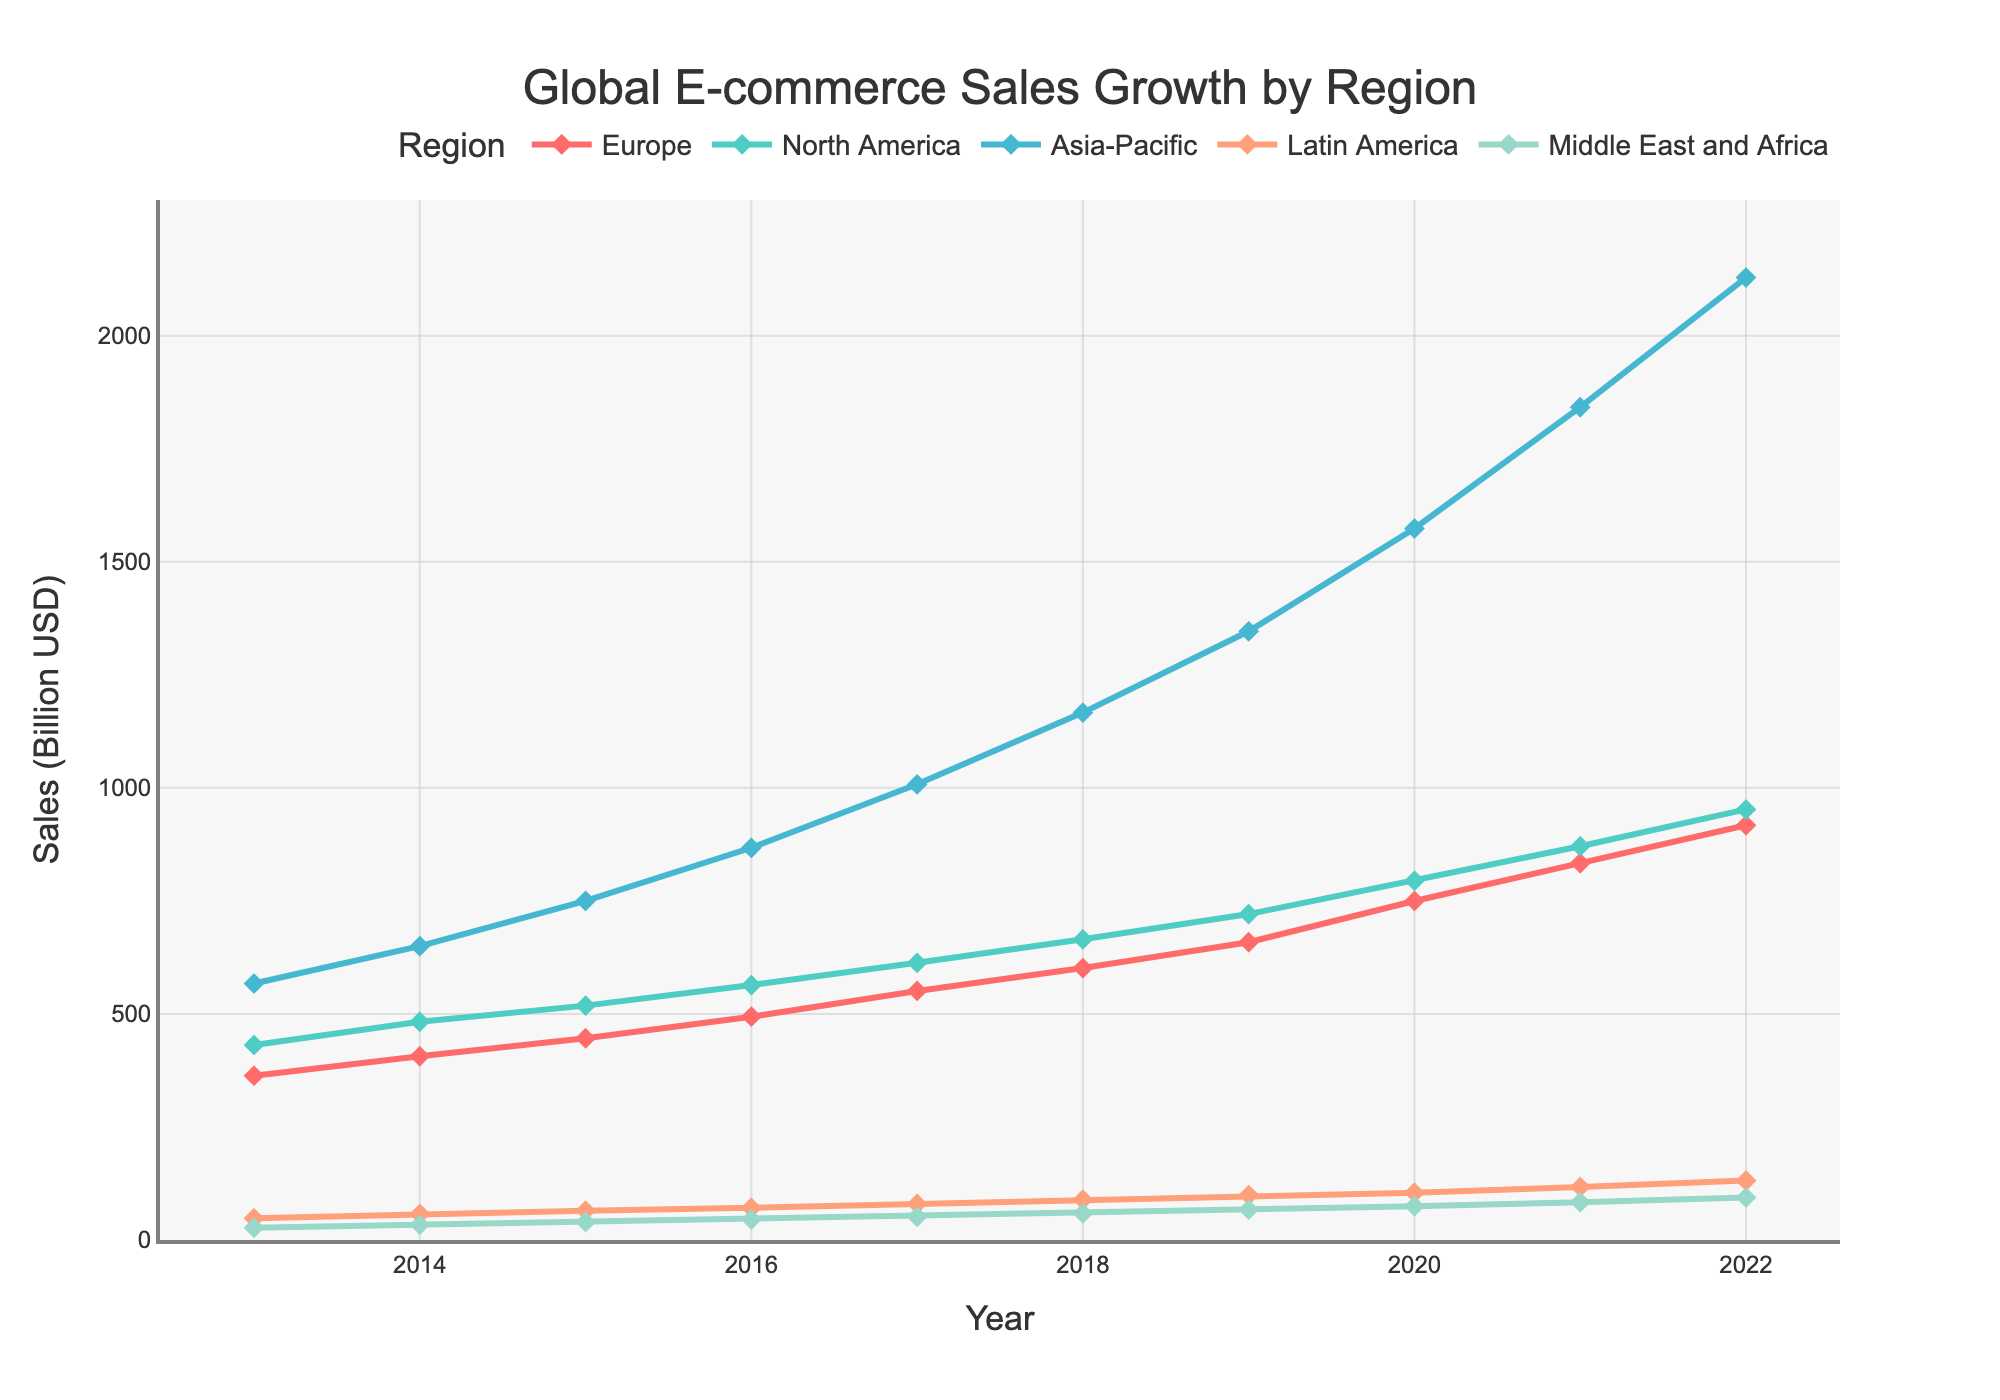What is the growth in e-commerce sales in the Asia-Pacific region from 2013 to 2022? To calculate the growth, subtract the sales in 2013 from the sales in 2022. The sales in 2022 are 2128.4 billion USD and in 2013 are 567.3 billion USD. So, the growth is 2128.4 - 567.3 = 1561.1 billion USD.
Answer: 1561.1 billion USD Which region had the highest e-commerce sales in 2022? To determine this, look at the sales figures for each region in 2022 and identify the highest number. The highest e-commerce sales in 2022 were in the Asia-Pacific region with 2128.4 billion USD.
Answer: Asia-Pacific What was the total e-commerce sales in 2020 for all regions combined? Sum the sales figures for all regions in 2020. The figures are 749.7 (Europe) + 794.5 (North America) + 1573.5 (Asia-Pacific) + 104.6 (Latin America) + 74.8 (Middle East and Africa) = 3297.1 billion USD.
Answer: 3297.1 billion USD How does the e-commerce sales growth in Europe from 2013 to 2022 compare to the growth in North America during the same period? First, calculate the growth for each region by subtracting 2013 sales from 2022 sales. For Europe, the growth is 917.3 - 363.1 = 554.2 billion USD. For North America, the growth is 952.2 - 431.2 = 521.0 billion USD. Then, compare 554.2 (Europe) to 521.0 (North America).
Answer: Europe had higher growth What is the average e-commerce sales in Latin America from 2013 to 2022? First, sum up all the sales figures for Latin America from 2013 to 2022, which are 48.1 + 57.7 + 64.9 + 71.2 + 79.7 + 89.1 + 99.4 + 104.6 + 117.2 + 131.3 = 863.2 billion USD. Then, divide by the number of years (10). The average is 863.2 / 10 =87.32 billion USD.
Answer: 87.32 billion USD By how much did e-commerce sales in the Latin America region grow from 2017 to 2020? Subtract the sales value of 2017 from 2020. The sales in 2020 are 104.6 billion USD, and in 2017 are 79.7 billion USD. The growth is 104.6 - 79.7 = 24.9 billion USD.
Answer: 24.9 billion USD 